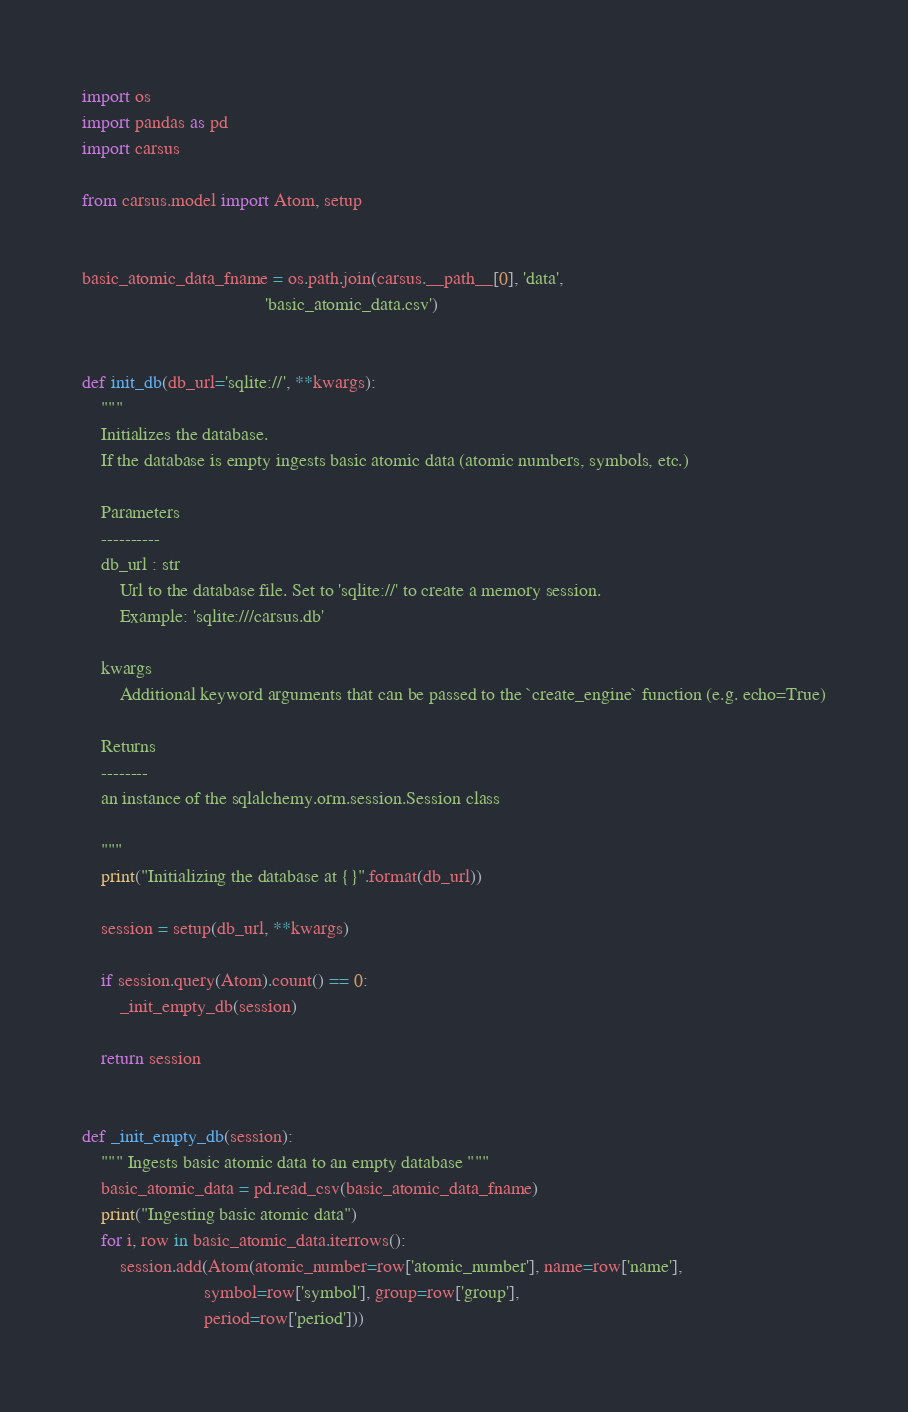<code> <loc_0><loc_0><loc_500><loc_500><_Python_>import os
import pandas as pd
import carsus

from carsus.model import Atom, setup


basic_atomic_data_fname = os.path.join(carsus.__path__[0], 'data',
                                       'basic_atomic_data.csv')


def init_db(db_url='sqlite://', **kwargs):
    """
    Initializes the database.
    If the database is empty ingests basic atomic data (atomic numbers, symbols, etc.)

    Parameters
    ----------
    db_url : str
        Url to the database file. Set to 'sqlite://' to create a memory session.
        Example: 'sqlite:///carsus.db'

    kwargs
        Additional keyword arguments that can be passed to the `create_engine` function (e.g. echo=True)

    Returns
    --------
    an instance of the sqlalchemy.orm.session.Session class

    """
    print("Initializing the database at {}".format(db_url))

    session = setup(db_url, **kwargs)

    if session.query(Atom).count() == 0:
        _init_empty_db(session)

    return session


def _init_empty_db(session):
    """ Ingests basic atomic data to an empty database """
    basic_atomic_data = pd.read_csv(basic_atomic_data_fname)
    print("Ingesting basic atomic data")
    for i, row in basic_atomic_data.iterrows():
        session.add(Atom(atomic_number=row['atomic_number'], name=row['name'],
                          symbol=row['symbol'], group=row['group'],
                          period=row['period']))
</code> 